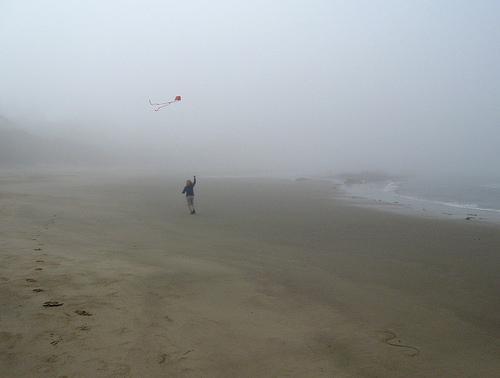How many people?
Give a very brief answer. 1. How many peole hold a chair in the beach?
Give a very brief answer. 0. 